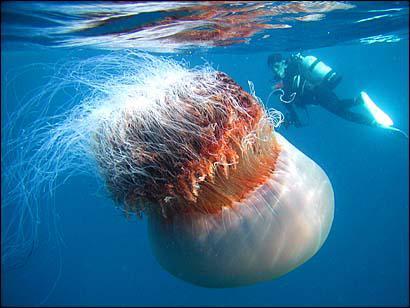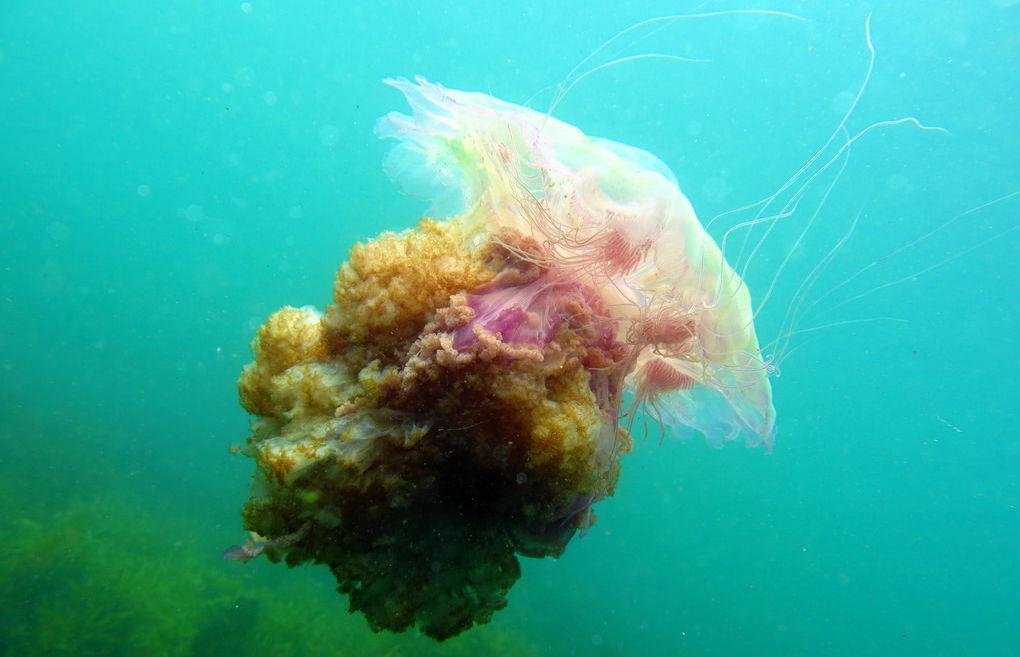The first image is the image on the left, the second image is the image on the right. For the images displayed, is the sentence "One scuba diver is to the right of a jelly fish." factually correct? Answer yes or no. Yes. The first image is the image on the left, the second image is the image on the right. For the images displayed, is the sentence "The left image contains one human scuba diving." factually correct? Answer yes or no. Yes. 